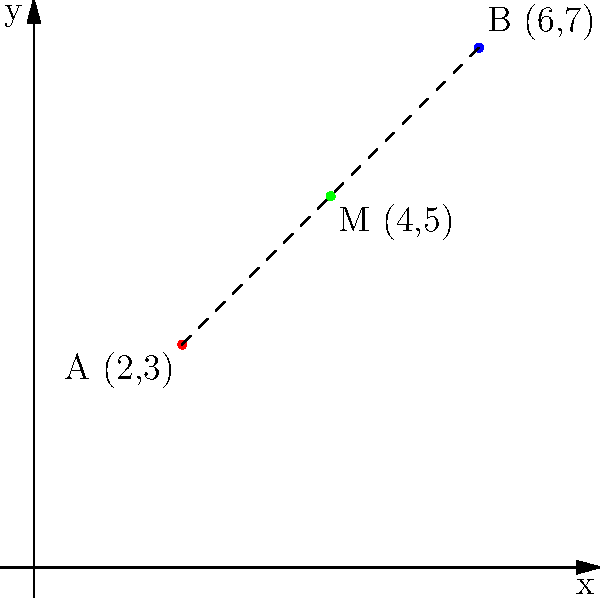As a tech journalist interviewing a sociolinguist, you're discussing the geographical centers of two language communities. The centers are represented by coordinates A (2,3) and B (6,7) on a map. What are the coordinates of the midpoint M between these two language communities? How might this midpoint be significant in understanding language diffusion or interaction between the two communities? To find the midpoint between two coordinates, we use the midpoint formula:

$$ M_x = \frac{x_1 + x_2}{2}, M_y = \frac{y_1 + y_2}{2} $$

Where $(x_1, y_1)$ are the coordinates of point A and $(x_2, y_2)$ are the coordinates of point B.

Step 1: Identify the coordinates
A: $(x_1, y_1) = (2, 3)$
B: $(x_2, y_2) = (6, 7)$

Step 2: Calculate the x-coordinate of the midpoint
$$ M_x = \frac{x_1 + x_2}{2} = \frac{2 + 6}{2} = \frac{8}{2} = 4 $$

Step 3: Calculate the y-coordinate of the midpoint
$$ M_y = \frac{y_1 + y_2}{2} = \frac{3 + 7}{2} = \frac{10}{2} = 5 $$

Therefore, the coordinates of the midpoint M are (4, 5).

Significance: The midpoint could represent an area where the two language communities are most likely to interact or where language diffusion might be most prominent. It could be a potential site for bilingualism, language mixing, or the emergence of a pidgin or creole language. From a sociolinguistic perspective, this point might be of interest for studying language contact phenomena, linguistic landscapes, or patterns of language shift and maintenance.
Answer: (4, 5) 